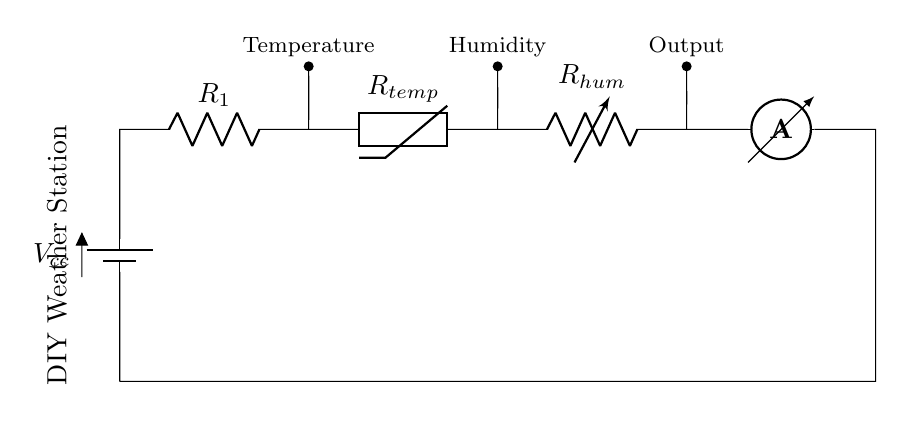What is the power supply voltage for the circuit? The power supply voltage is denoted as Vcc in the drawing, which indicates the voltage provided to the circuit.
Answer: Vcc What type of resistors are used in this circuit? The circuit diagram shows a fixed resistor labeled R1, a thermistor labeled Rtemp for temperature sensing, and a variable resistor labeled Rhum for humidity sensing.
Answer: Fixed and variable resistors Which component measures current in the circuit? The ammeter is included in the diagram, which is used to measure the current flowing through the circuit.
Answer: Ammeter What is the purpose of the thermistor in this circuit? The thermistor, labeled Rtemp, is used to detect temperature changes by varying its resistance according to the temperature, giving input for temperature measurement.
Answer: Temperature sensing How many sensors are in this weather station circuit? The circuit includes two sensors: one for temperature (thermistor) and one for humidity (variable resistor), which are part of the weather station setup.
Answer: Two sensors What will happen to the readings if the resistance of the variable resistor increases? When the resistance of the variable resistor (Rhum) increases, the overall current through the circuit decreases, which can cause the output reading for humidity to reflect lower humidity levels.
Answer: Decrease in current What kind of circuit is depicted in the diagram? The circuit is a series circuit, as all components (battery, resistors, and ammeter) are connected in a single path for current flow.
Answer: Series circuit 